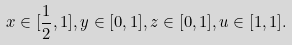Convert formula to latex. <formula><loc_0><loc_0><loc_500><loc_500>x \in [ \frac { 1 } { 2 } , 1 ] , y \in [ 0 , 1 ] , z \in [ 0 , 1 ] , u \in [ 1 , 1 ] .</formula> 